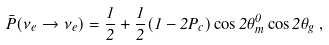Convert formula to latex. <formula><loc_0><loc_0><loc_500><loc_500>\bar { P } ( \nu _ { e } \rightarrow \nu _ { e } ) = \frac { 1 } { 2 } + \frac { 1 } { 2 } ( 1 - 2 P _ { c } ) \cos 2 \theta _ { m } ^ { 0 } \cos 2 \theta _ { g } \, ,</formula> 